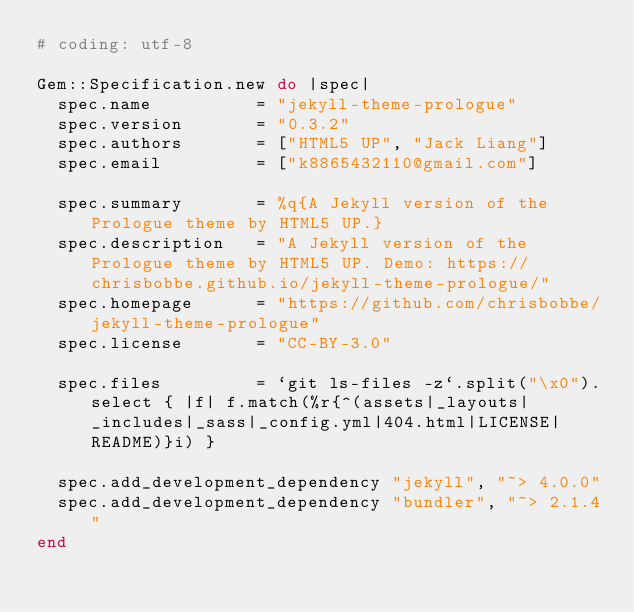<code> <loc_0><loc_0><loc_500><loc_500><_Ruby_># coding: utf-8

Gem::Specification.new do |spec|
  spec.name          = "jekyll-theme-prologue"
  spec.version       = "0.3.2"
  spec.authors       = ["HTML5 UP", "Jack Liang"]
  spec.email         = ["k8865432110@gmail.com"]

  spec.summary       = %q{A Jekyll version of the Prologue theme by HTML5 UP.}
  spec.description   = "A Jekyll version of the Prologue theme by HTML5 UP. Demo: https://chrisbobbe.github.io/jekyll-theme-prologue/"
  spec.homepage      = "https://github.com/chrisbobbe/jekyll-theme-prologue"
  spec.license       = "CC-BY-3.0"

  spec.files         = `git ls-files -z`.split("\x0").select { |f| f.match(%r{^(assets|_layouts|_includes|_sass|_config.yml|404.html|LICENSE|README)}i) }

  spec.add_development_dependency "jekyll", "~> 4.0.0"
  spec.add_development_dependency "bundler", "~> 2.1.4"
end
</code> 